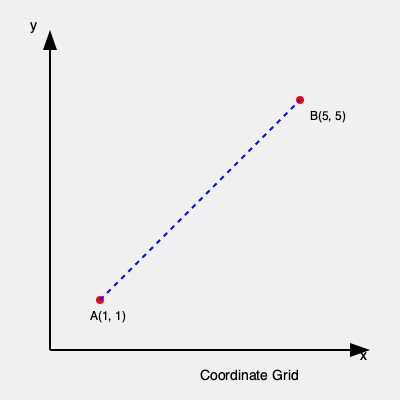As a retired software developer familiar with Excel, you know that calculating slopes is often useful in data analysis. Given two points A(1, 1) and B(5, 5) on the coordinate grid shown above, what is the slope of the line passing through these points? Express your answer as a decimal. To find the slope of a line given two points, we can use the slope formula:

$$ \text{slope} = m = \frac{y_2 - y_1}{x_2 - x_1} $$

Where $(x_1, y_1)$ represents the coordinates of the first point and $(x_2, y_2)$ represents the coordinates of the second point.

Let's follow these steps:

1. Identify the coordinates:
   Point A: $(x_1, y_1) = (1, 1)$
   Point B: $(x_2, y_2) = (5, 5)$

2. Apply the slope formula:
   $$ m = \frac{y_2 - y_1}{x_2 - x_1} = \frac{5 - 1}{5 - 1} $$

3. Simplify:
   $$ m = \frac{4}{4} = 1 $$

4. Express the result as a decimal:
   $$ m = 1.0 $$

Therefore, the slope of the line passing through points A(1, 1) and B(5, 5) is 1.0.
Answer: 1.0 